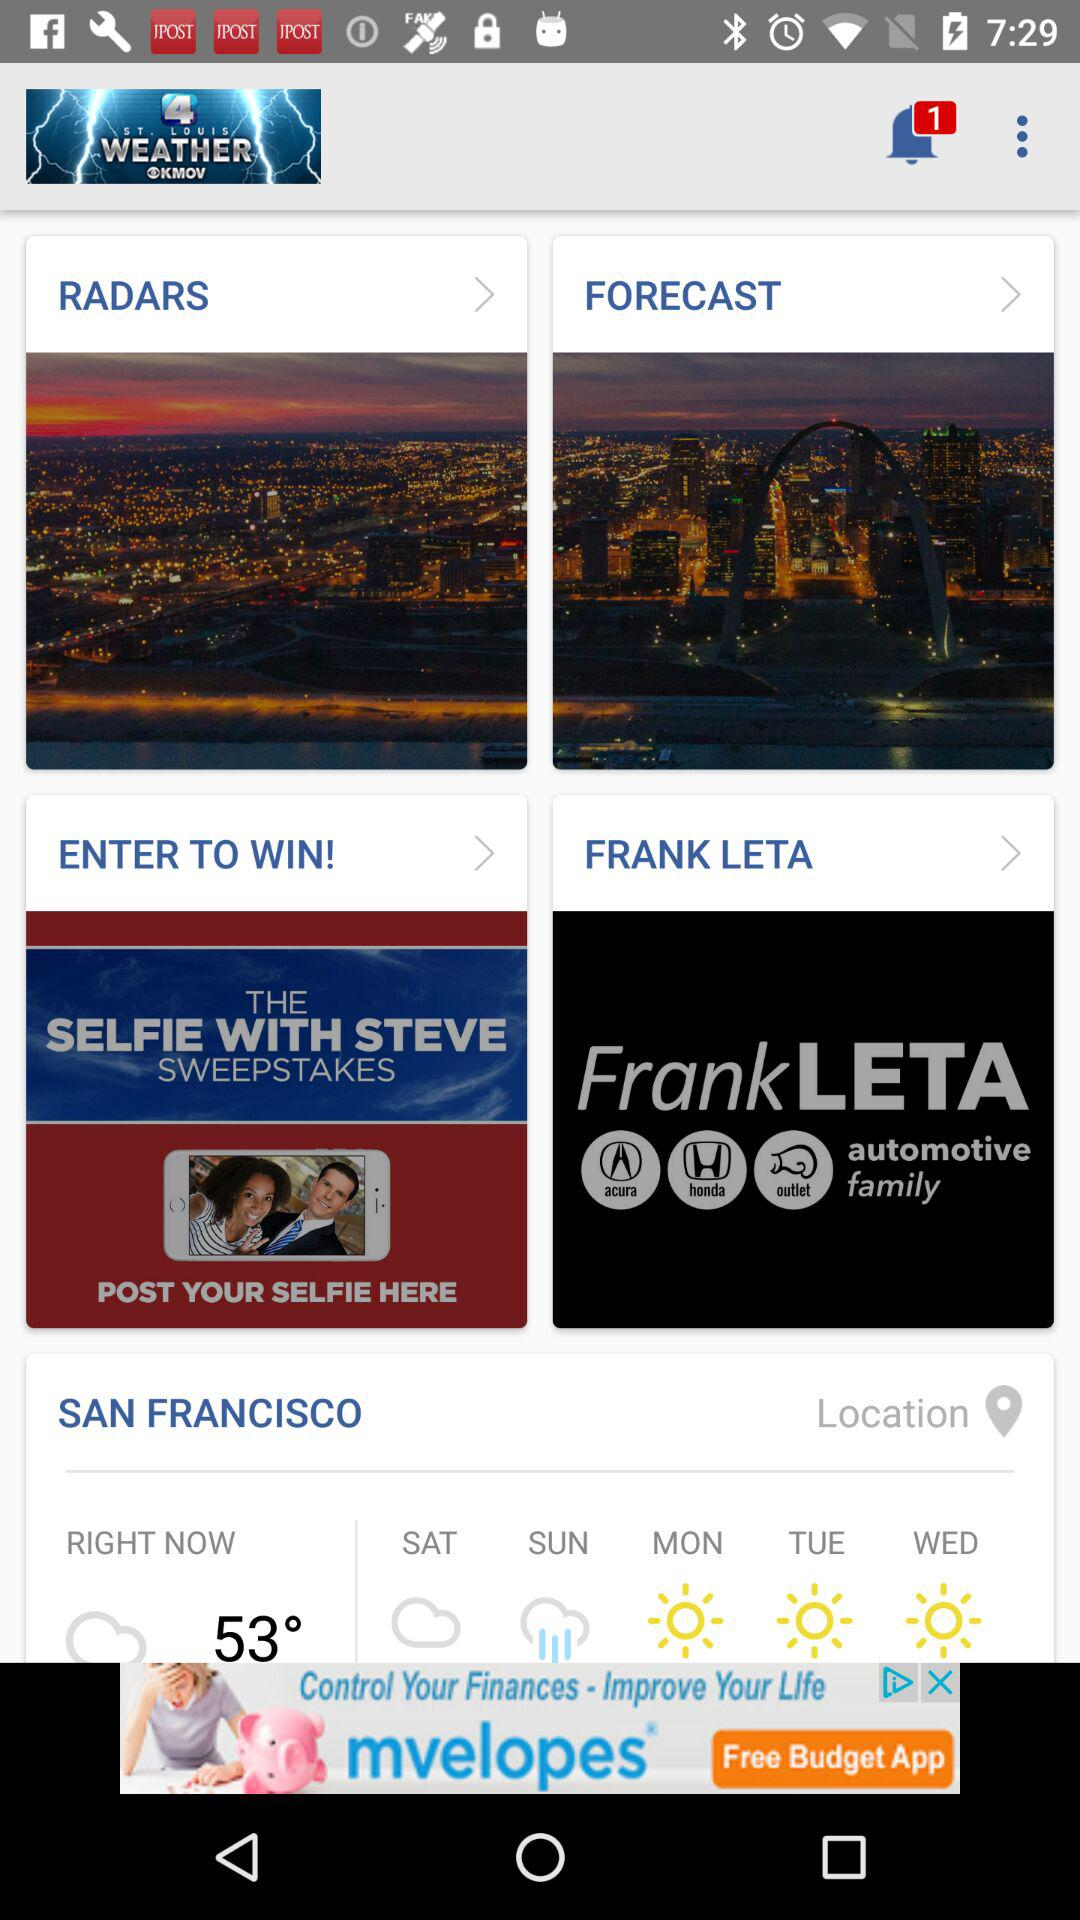What is the location? The location is San Francisco. 